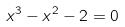<formula> <loc_0><loc_0><loc_500><loc_500>x ^ { 3 } - x ^ { 2 } - 2 = 0</formula> 